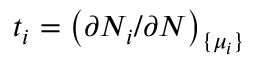<formula> <loc_0><loc_0><loc_500><loc_500>t _ { i } = \left ( \partial N _ { i } / \partial N \right ) _ { \{ \mu _ { i } \} }</formula> 